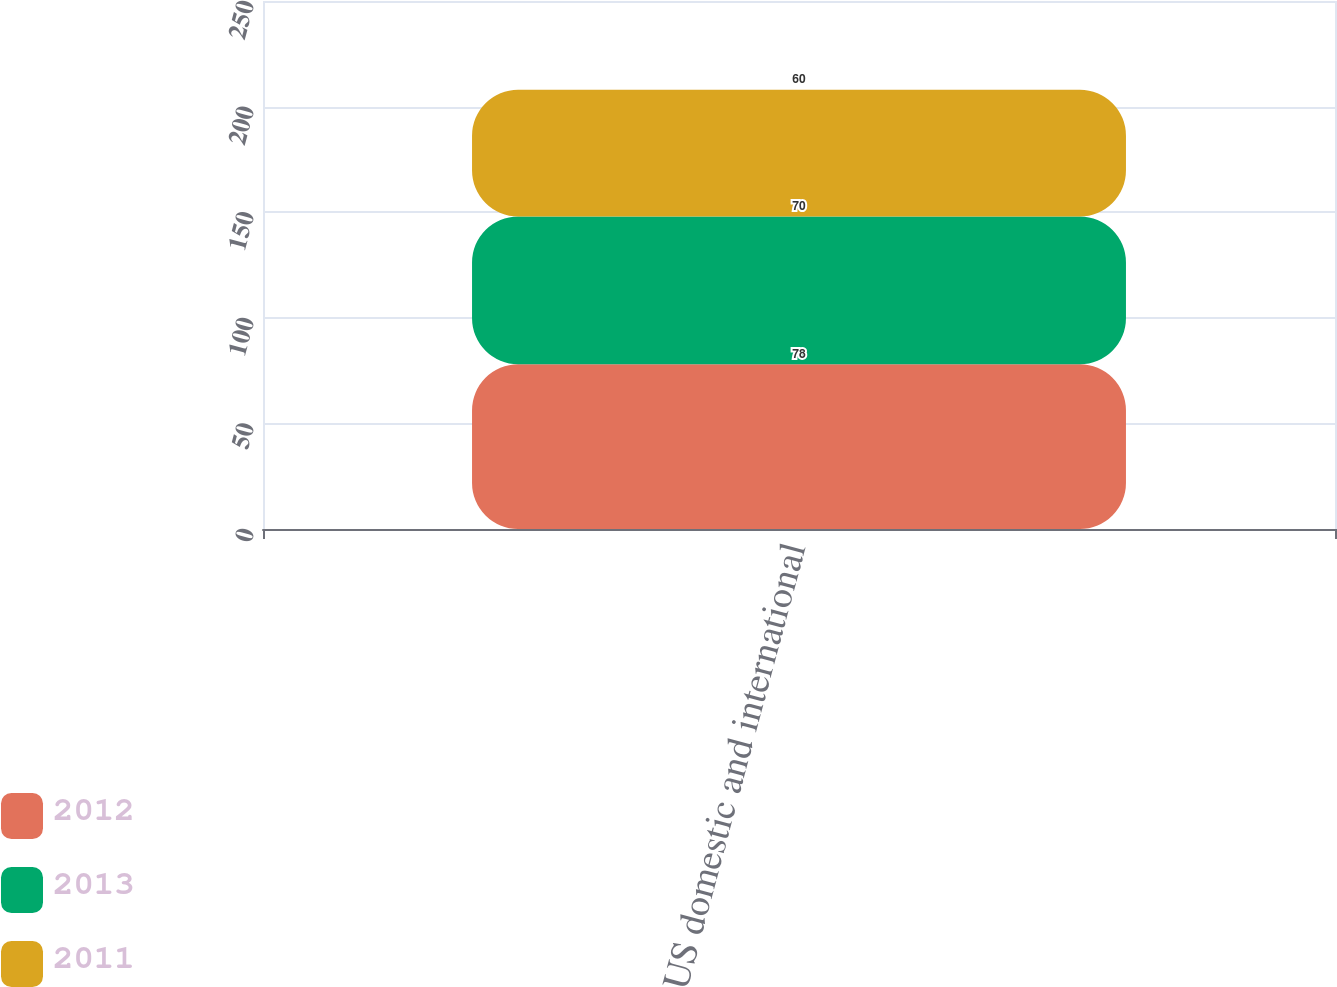Convert chart to OTSL. <chart><loc_0><loc_0><loc_500><loc_500><stacked_bar_chart><ecel><fcel>US domestic and international<nl><fcel>2012<fcel>78<nl><fcel>2013<fcel>70<nl><fcel>2011<fcel>60<nl></chart> 